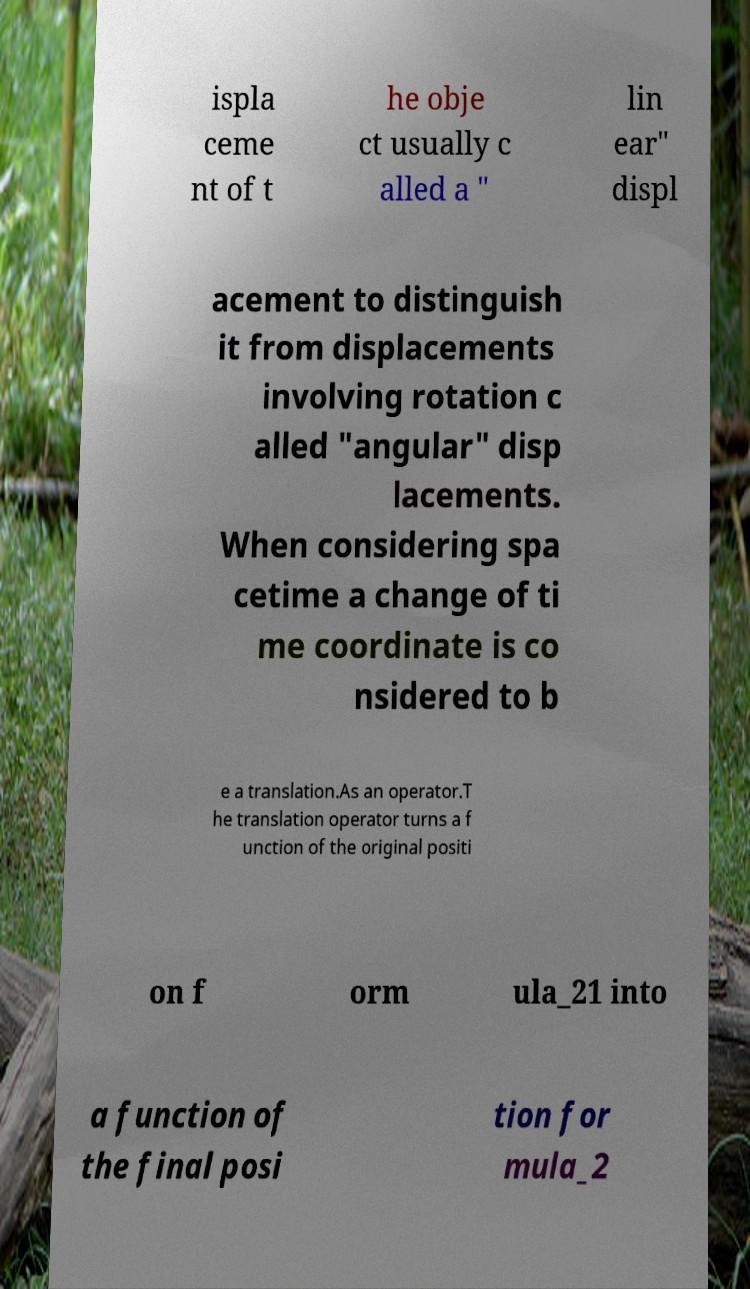Could you extract and type out the text from this image? ispla ceme nt of t he obje ct usually c alled a " lin ear" displ acement to distinguish it from displacements involving rotation c alled "angular" disp lacements. When considering spa cetime a change of ti me coordinate is co nsidered to b e a translation.As an operator.T he translation operator turns a f unction of the original positi on f orm ula_21 into a function of the final posi tion for mula_2 